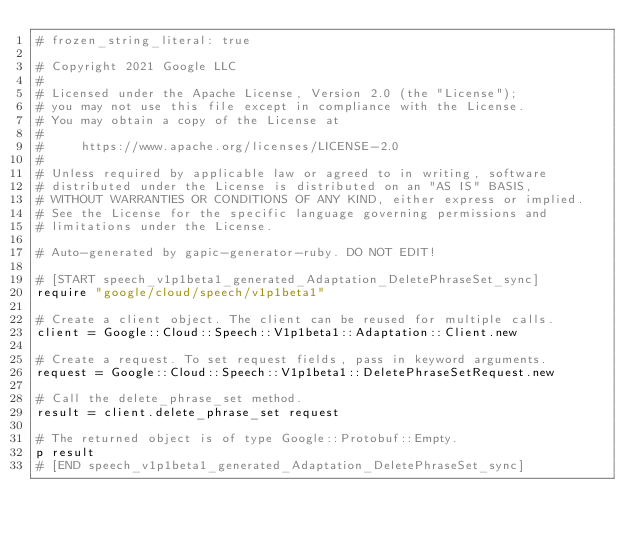Convert code to text. <code><loc_0><loc_0><loc_500><loc_500><_Ruby_># frozen_string_literal: true

# Copyright 2021 Google LLC
#
# Licensed under the Apache License, Version 2.0 (the "License");
# you may not use this file except in compliance with the License.
# You may obtain a copy of the License at
#
#     https://www.apache.org/licenses/LICENSE-2.0
#
# Unless required by applicable law or agreed to in writing, software
# distributed under the License is distributed on an "AS IS" BASIS,
# WITHOUT WARRANTIES OR CONDITIONS OF ANY KIND, either express or implied.
# See the License for the specific language governing permissions and
# limitations under the License.

# Auto-generated by gapic-generator-ruby. DO NOT EDIT!

# [START speech_v1p1beta1_generated_Adaptation_DeletePhraseSet_sync]
require "google/cloud/speech/v1p1beta1"

# Create a client object. The client can be reused for multiple calls.
client = Google::Cloud::Speech::V1p1beta1::Adaptation::Client.new

# Create a request. To set request fields, pass in keyword arguments.
request = Google::Cloud::Speech::V1p1beta1::DeletePhraseSetRequest.new

# Call the delete_phrase_set method.
result = client.delete_phrase_set request

# The returned object is of type Google::Protobuf::Empty.
p result
# [END speech_v1p1beta1_generated_Adaptation_DeletePhraseSet_sync]
</code> 